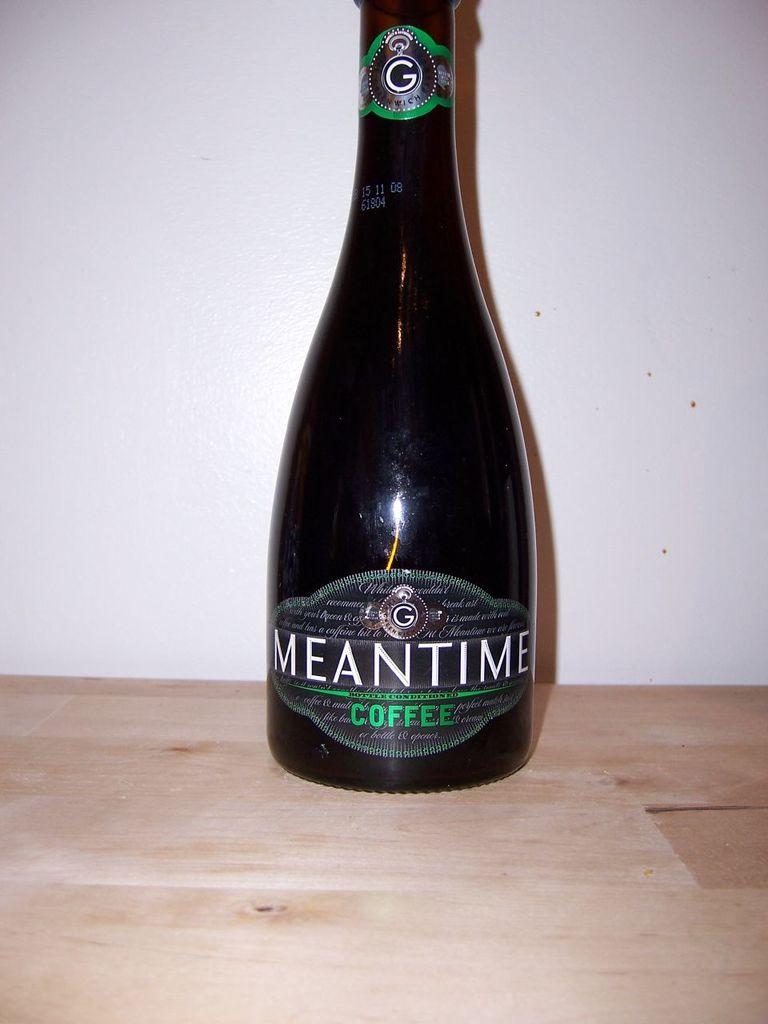What is the letter on the bottle?
Give a very brief answer. G. 